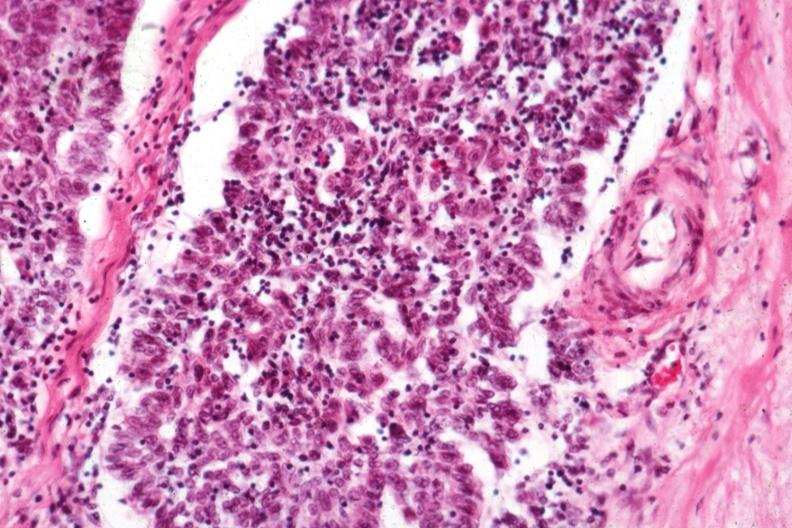s hematologic present?
Answer the question using a single word or phrase. Yes 